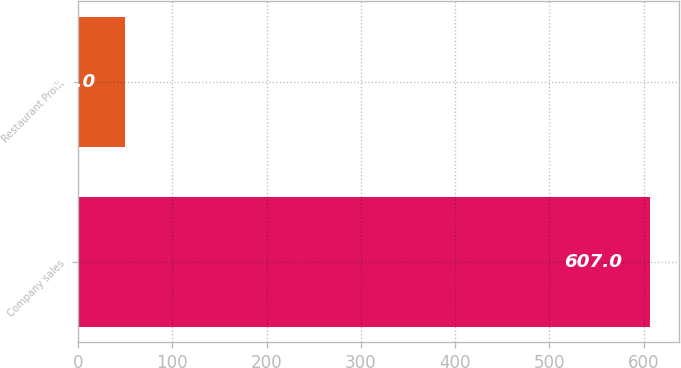Convert chart to OTSL. <chart><loc_0><loc_0><loc_500><loc_500><bar_chart><fcel>Company sales<fcel>Restaurant Profit<nl><fcel>607<fcel>50<nl></chart> 